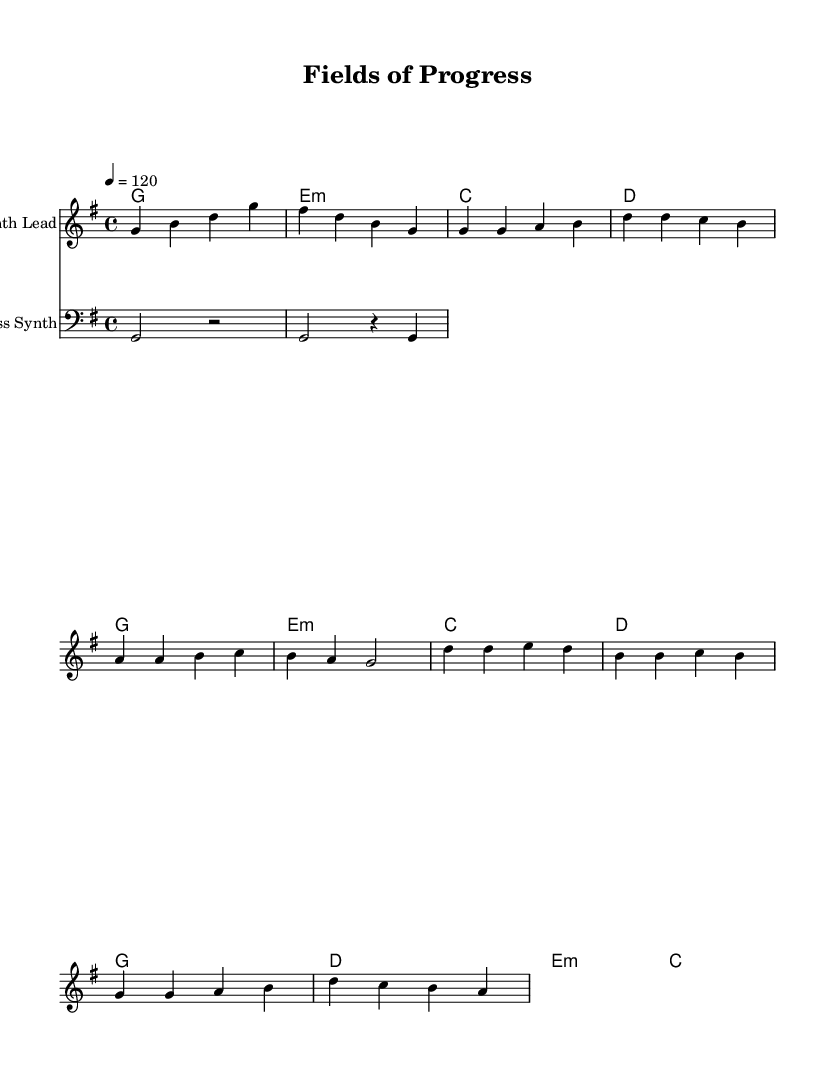What is the key signature of this music? The key signature is identified by the sharps or flats at the beginning of the staff. In this case, there are no sharps or flats, indicating it is in G major.
Answer: G major What is the time signature for this composition? The time signature is found at the beginning of the sheet music, indicating how many beats are in a measure. Here, it shows 4/4, which means there are four beats per measure.
Answer: 4/4 What is the tempo marking of the piece? The tempo marking indicates the speed of the music and is shown in the score. It states "4 = 120", which means there are 120 beats per minute, with the quarter note getting the beat.
Answer: 120 How many measures are there in the intro section? The intro section consists of two measures, which can be counted in the "melody" part of the sheet music before the verse begins.
Answer: 2 Which instrument is indicated for the melody? The instrument name can be seen above the staff in the score. It clearly states "Synth Lead" for the melody part of the music.
Answer: Synth Lead What type of chord is used in the first measure of the intro? The first measure of the intro contains a "G" chord, which is represented as a "g1" in the harmonies section, indicating a G major chord.
Answer: G What is the structure of this piece with respect to its sections? By analyzing the order of the musical sections in the score, it can be determined that the piece follows an intro, then a verse, followed by a chorus, indicating a common song structure.
Answer: Intro, Verse, Chorus 